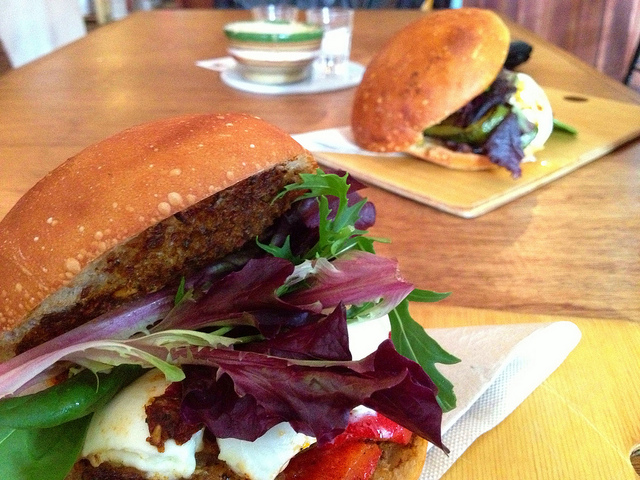How many sandwiches are in the photo? There are two delicious-looking sandwiches in the photo, each packed with an assortment of fresh greens and toppings, served on wooden boards for a rustic appeal. 